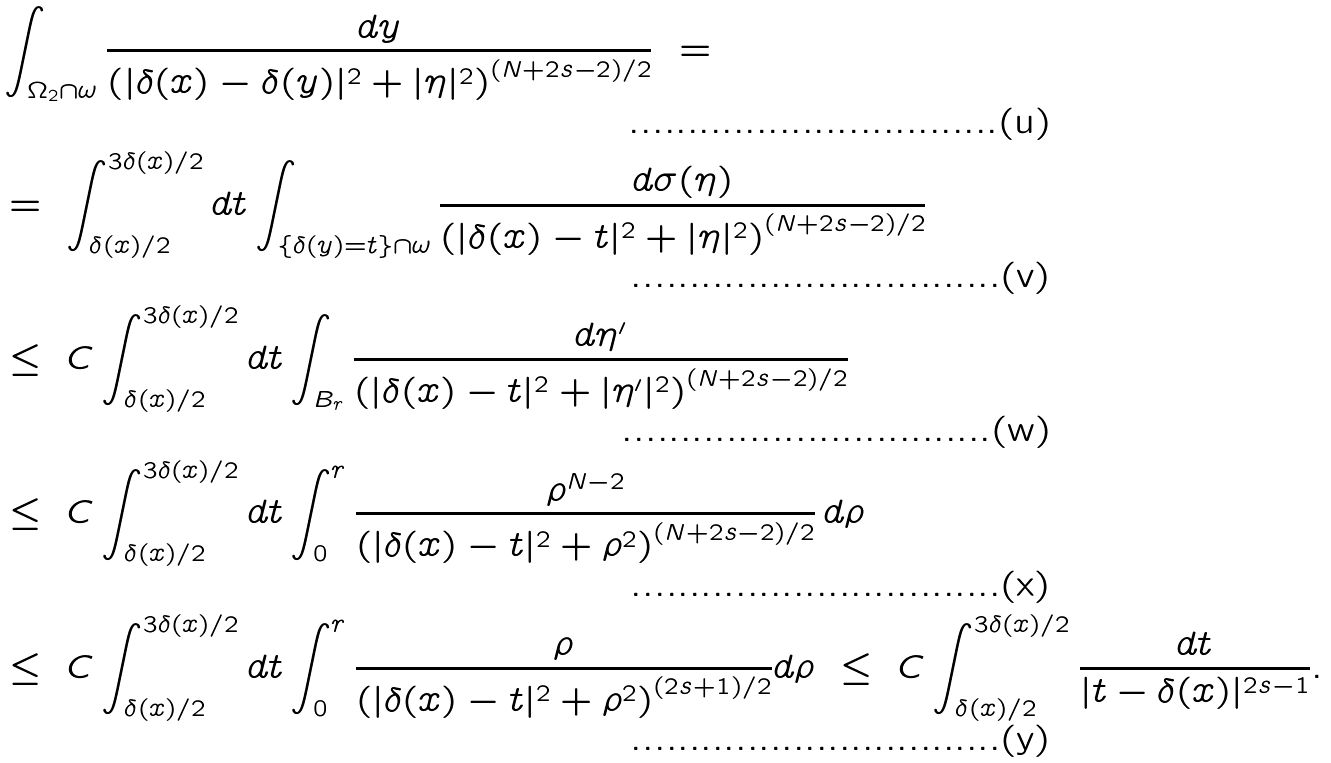Convert formula to latex. <formula><loc_0><loc_0><loc_500><loc_500>& \int _ { \Omega _ { 2 } \cap \omega } \frac { d y } { \left ( | \delta ( x ) - \delta ( y ) | ^ { 2 } + | \eta | ^ { 2 } \right ) ^ { ( N + 2 s - 2 ) / 2 } } \ = \\ & = \ \int _ { \delta ( x ) / 2 } ^ { 3 \delta ( x ) / 2 } d t \int _ { \{ \delta ( y ) = t \} \cap \omega } \frac { d \sigma ( \eta ) } { \left ( | \delta ( x ) - t | ^ { 2 } + | \eta | ^ { 2 } \right ) ^ { ( N + 2 s - 2 ) / 2 } } \\ & \leq \ C \int _ { \delta ( x ) / 2 } ^ { 3 \delta ( x ) / 2 } d t \int _ { B _ { r } } \frac { d \eta ^ { \prime } } { \left ( | \delta ( x ) - t | ^ { 2 } + | \eta ^ { \prime } | ^ { 2 } \right ) ^ { ( N + 2 s - 2 ) / 2 } } \\ & \leq \ C \int _ { \delta ( x ) / 2 } ^ { 3 \delta ( x ) / 2 } d t \int _ { 0 } ^ { r } \frac { \rho ^ { N - 2 } } { \left ( | \delta ( x ) - t | ^ { 2 } + \rho ^ { 2 } \right ) ^ { ( N + 2 s - 2 ) / 2 } } \, d \rho \\ & \leq \ C \int _ { \delta ( x ) / 2 } ^ { 3 \delta ( x ) / 2 } d t \int _ { 0 } ^ { r } \frac { \rho } { \left ( | \delta ( x ) - t | ^ { 2 } + \rho ^ { 2 } \right ) ^ { ( 2 s + 1 ) / 2 } } d \rho \ \leq \ C \int _ { \delta ( x ) / 2 } ^ { 3 \delta ( x ) / 2 } \frac { d t } { | t - \delta ( x ) | ^ { 2 s - 1 } } .</formula> 